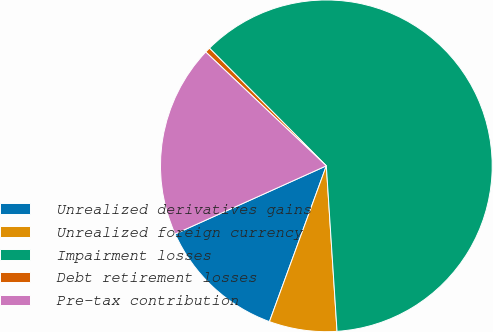Convert chart. <chart><loc_0><loc_0><loc_500><loc_500><pie_chart><fcel>Unrealized derivatives gains<fcel>Unrealized foreign currency<fcel>Impairment losses<fcel>Debt retirement losses<fcel>Pre-tax contribution<nl><fcel>12.69%<fcel>6.6%<fcel>61.42%<fcel>0.51%<fcel>18.78%<nl></chart> 